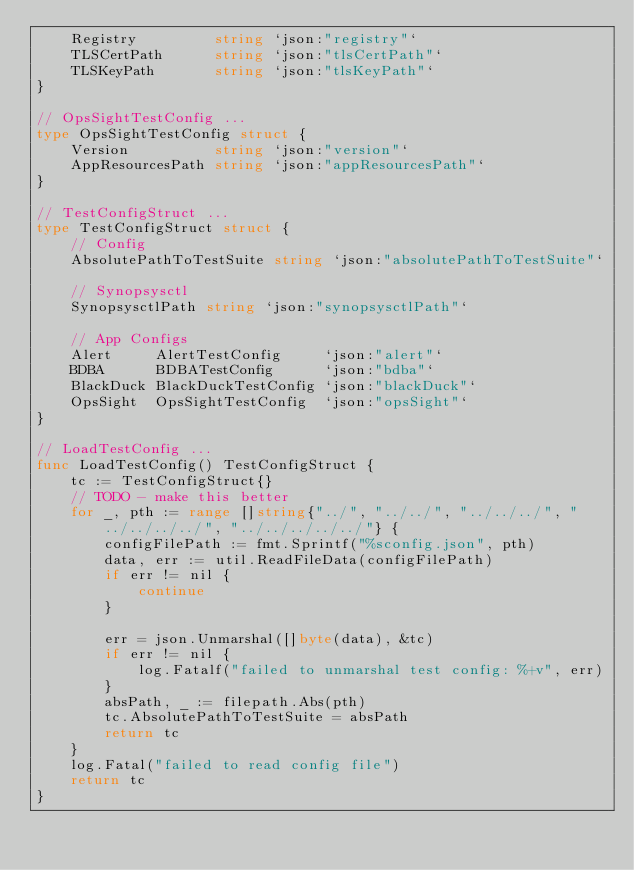<code> <loc_0><loc_0><loc_500><loc_500><_Go_>	Registry         string `json:"registry"`
	TLSCertPath      string `json:"tlsCertPath"`
	TLSKeyPath       string `json:"tlsKeyPath"`
}

// OpsSightTestConfig ...
type OpsSightTestConfig struct {
	Version          string `json:"version"`
	AppResourcesPath string `json:"appResourcesPath"`
}

// TestConfigStruct ...
type TestConfigStruct struct {
	// Config
	AbsolutePathToTestSuite string `json:"absolutePathToTestSuite"`

	// Synopsysctl
	SynopsysctlPath string `json:"synopsysctlPath"`

	// App Configs
	Alert     AlertTestConfig     `json:"alert"`
	BDBA      BDBATestConfig      `json:"bdba"`
	BlackDuck BlackDuckTestConfig `json:"blackDuck"`
	OpsSight  OpsSightTestConfig  `json:"opsSight"`
}

// LoadTestConfig ...
func LoadTestConfig() TestConfigStruct {
	tc := TestConfigStruct{}
	// TODO - make this better
	for _, pth := range []string{"../", "../../", "../../../", "../../../../", "../../../../../"} {
		configFilePath := fmt.Sprintf("%sconfig.json", pth)
		data, err := util.ReadFileData(configFilePath)
		if err != nil {
			continue
		}

		err = json.Unmarshal([]byte(data), &tc)
		if err != nil {
			log.Fatalf("failed to unmarshal test config: %+v", err)
		}
		absPath, _ := filepath.Abs(pth)
		tc.AbsolutePathToTestSuite = absPath
		return tc
	}
	log.Fatal("failed to read config file")
	return tc
}
</code> 